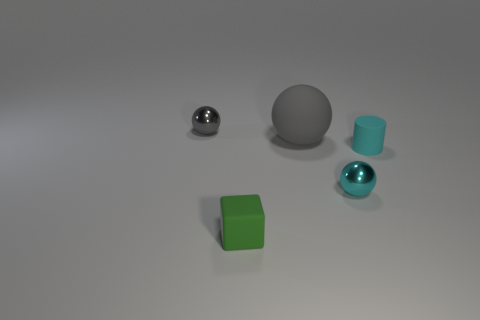What is the material of the cyan thing that is the same shape as the tiny gray metallic object?
Provide a short and direct response. Metal. There is a small ball right of the tiny gray sphere; is it the same color as the large matte sphere?
Make the answer very short. No. Is the big object made of the same material as the sphere in front of the large rubber object?
Offer a terse response. No. There is a tiny metal object on the right side of the large gray matte thing; what shape is it?
Offer a very short reply. Sphere. How many other objects are the same material as the cyan sphere?
Offer a very short reply. 1. What size is the green thing?
Provide a short and direct response. Small. How many other objects are there of the same color as the small cylinder?
Make the answer very short. 1. What is the color of the small thing that is left of the large ball and in front of the tiny rubber cylinder?
Provide a short and direct response. Green. How many blue blocks are there?
Give a very brief answer. 0. Is the large gray thing made of the same material as the cube?
Make the answer very short. Yes. 